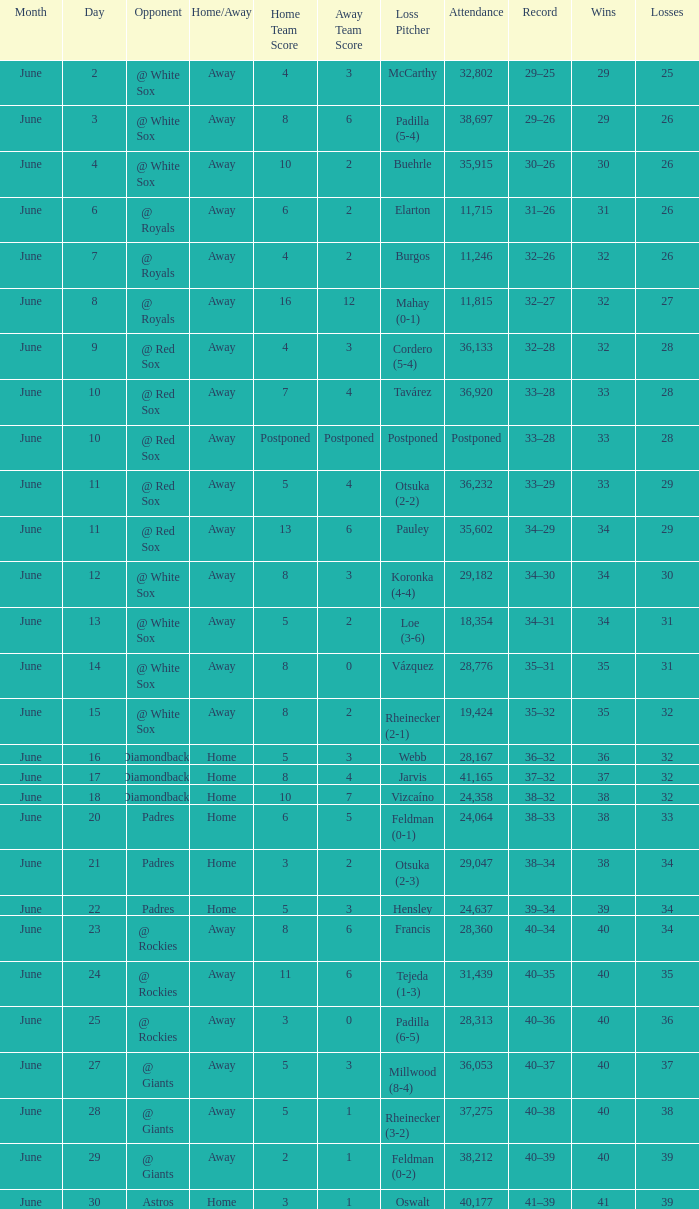When did tavárez lose? June 10. 